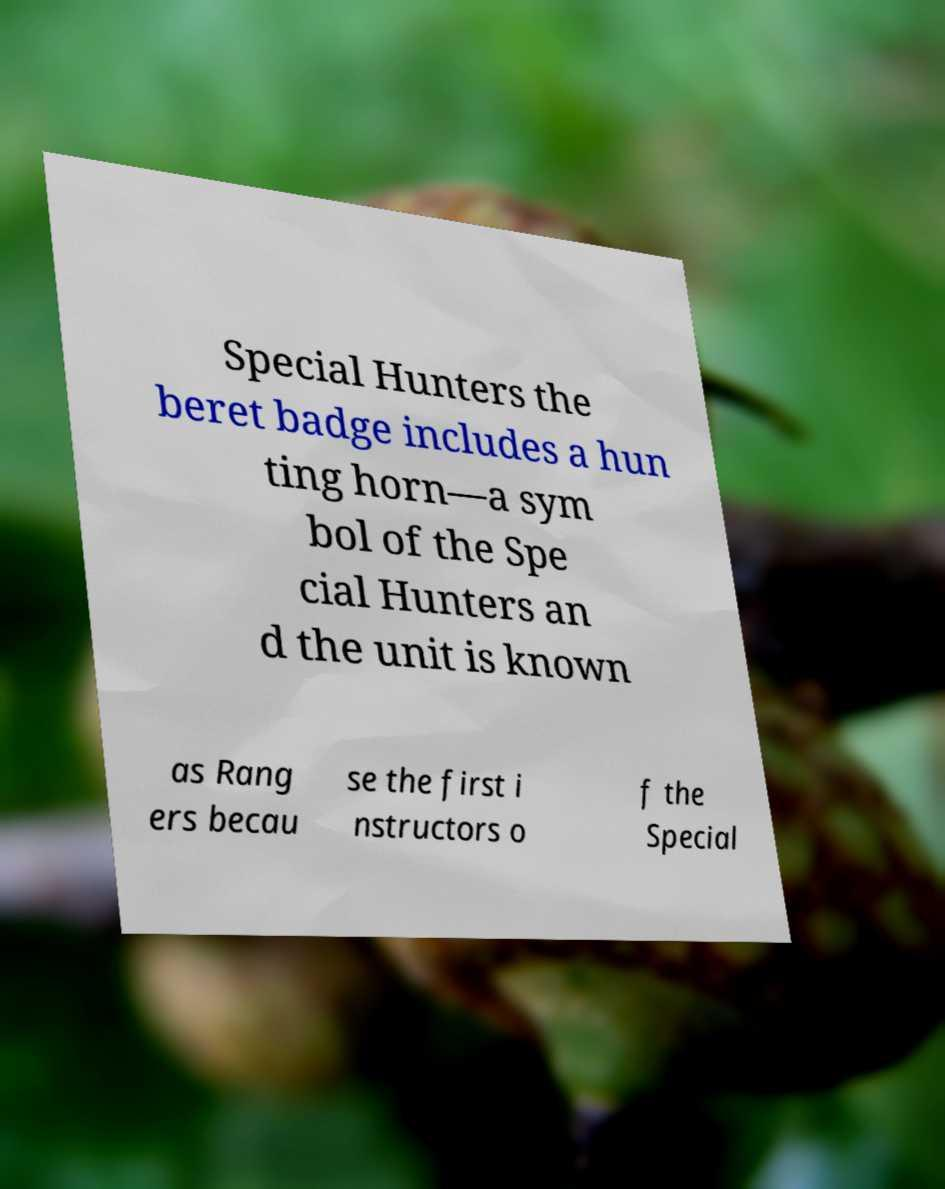Could you extract and type out the text from this image? Special Hunters the beret badge includes a hun ting horn—a sym bol of the Spe cial Hunters an d the unit is known as Rang ers becau se the first i nstructors o f the Special 